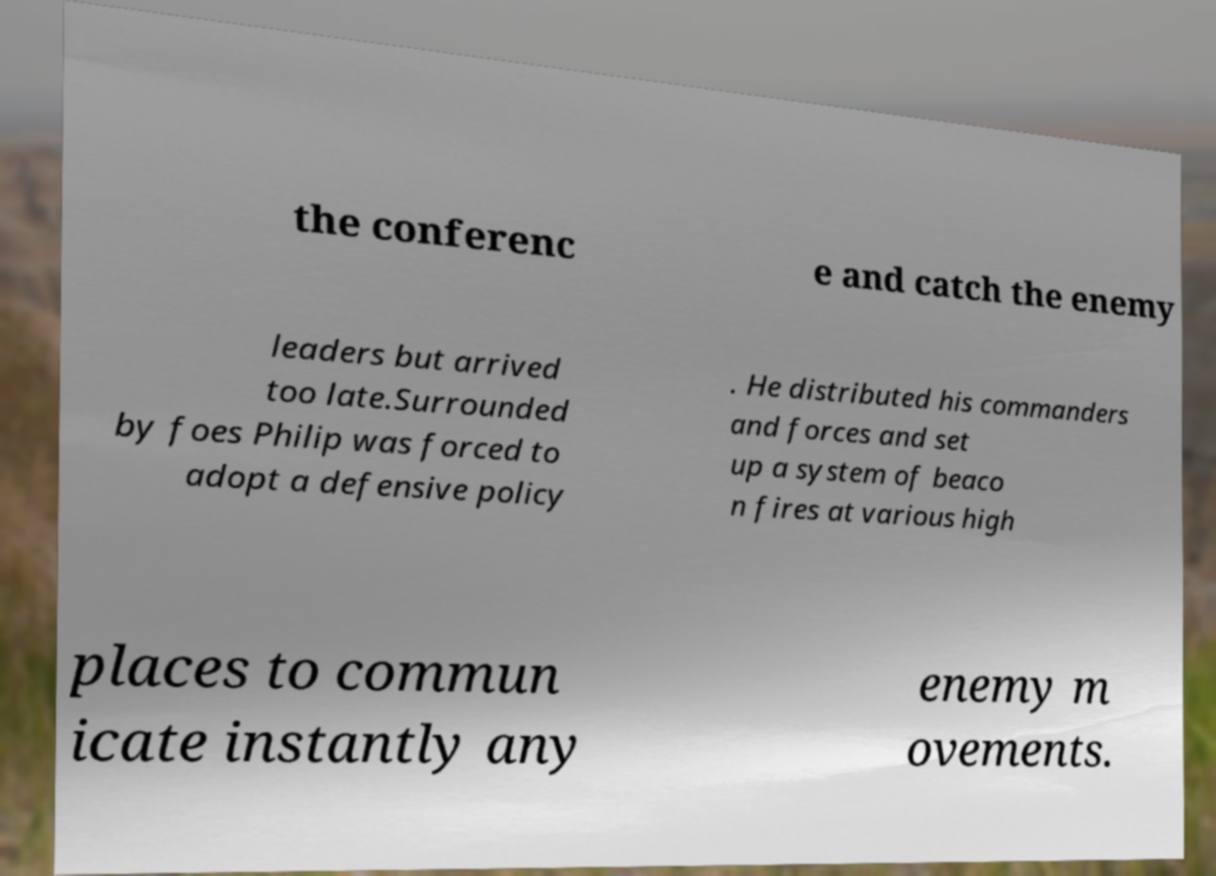What messages or text are displayed in this image? I need them in a readable, typed format. the conferenc e and catch the enemy leaders but arrived too late.Surrounded by foes Philip was forced to adopt a defensive policy . He distributed his commanders and forces and set up a system of beaco n fires at various high places to commun icate instantly any enemy m ovements. 